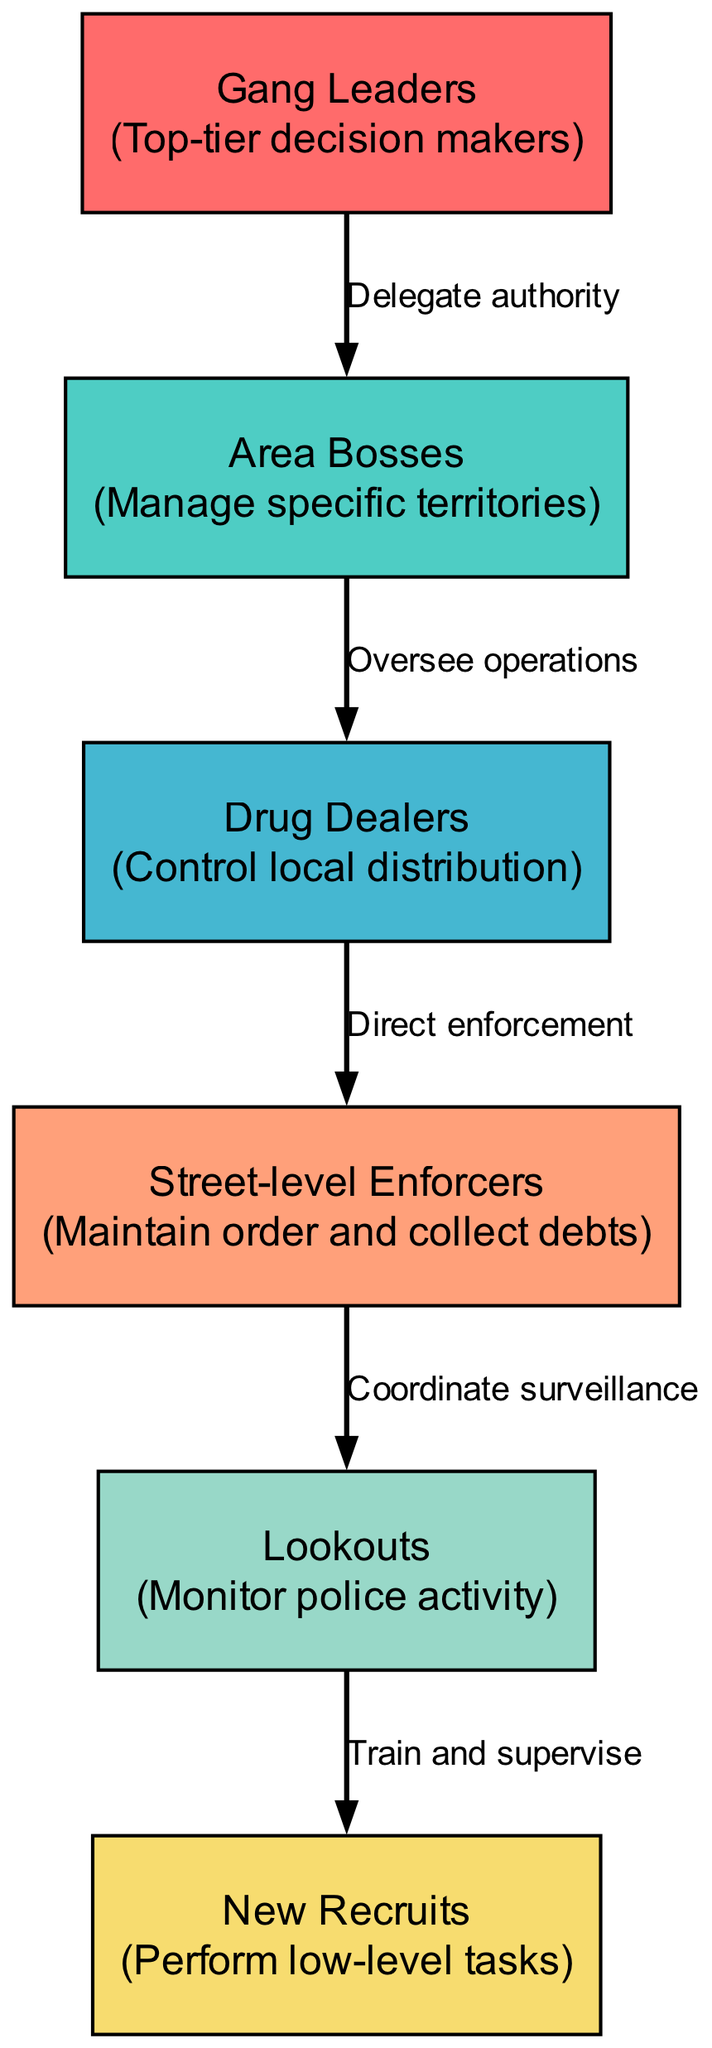What is the top tier of the gang structure? The top tier is labeled as "Gang Leaders," as indicated in the diagram. This node represents the highest level of authority and decision-making within the gang structure.
Answer: Gang Leaders Who is responsible for overseeing operations in specific areas? That responsibility falls to the "Area Bosses," who are tasked with managing specific territories as depicted in the diagram.
Answer: Area Bosses What level comes before "Street-level Enforcers"? The level that comes before "Street-level Enforcers" is "Drug Dealers," as shown in the hierarchical progression of the diagram.
Answer: Drug Dealers How many levels are represented in the gang structure? There are a total of 6 levels illustrated within the structure of the diagram, ranging from Gang Leaders down to New Recruits.
Answer: 6 Which role is responsible for monitoring police activity? The role responsible for monitoring police activity is depicted as "Lookouts," who play a key role in surveillance and information gathering.
Answer: Lookouts Explain the relationship between "Drug Dealers" and "Street-level Enforcers." The diagram describes that "Drug Dealers" directly instruct "Street-level Enforcers," indicating that the dealers are responsible for directing the actions and enforcement of street-level operations.
Answer: Direct enforcement Who trains and supervises "New Recruits"? "Lookouts" are tasked with training and supervising "New Recruits," showing a mentorship or guidance role within the gang hierarchy as indicated in the relationships section of the diagram.
Answer: Lookouts Which level has the most authority? The "Gang Leaders" hold the most authority in the diagram, positioned at the top of the hierarchy, demonstrating their role as primary decision-makers.
Answer: Gang Leaders What is the hierarchical level of "New Recruits"? "New Recruits" are positioned at the lowest hierarchical level, which is level 6 in the structure, performing low-level tasks without significant authority.
Answer: 6 